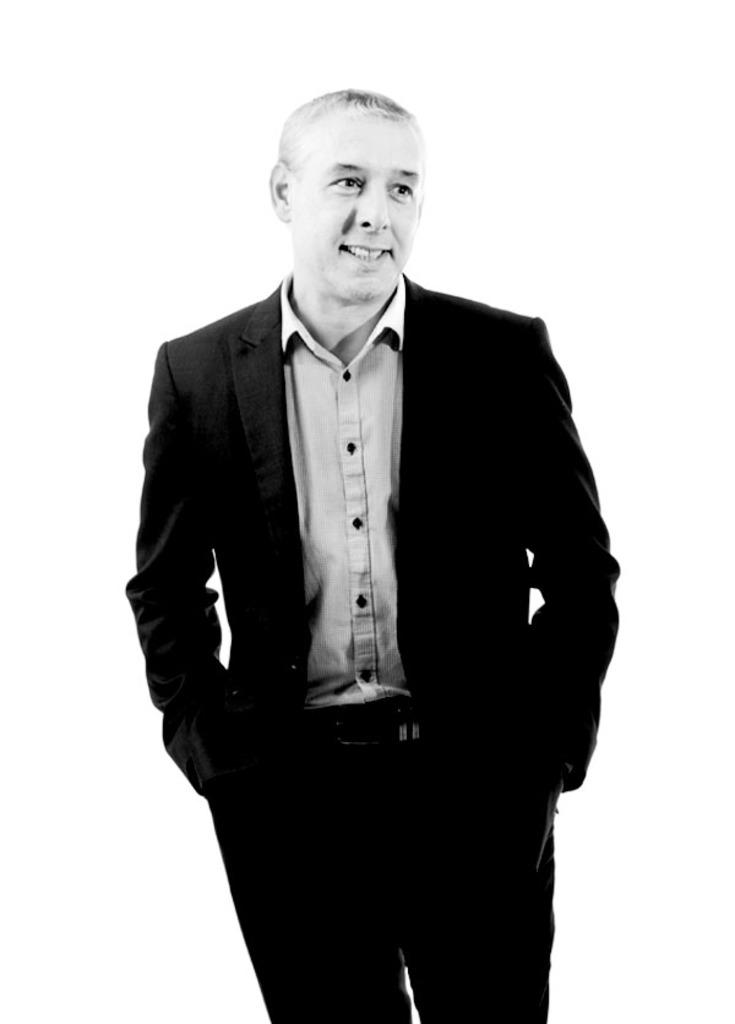What is present in the image? There is a man in the image. What is the man wearing? The man is wearing a suit. What is the color of the background in the image? The background of the image is white in color. What type of spoon is the governor using in the image? There is no governor or spoon present in the image. What type of scissors is the man holding in the image? There is no scissors present in the image; the man is only wearing a suit. 